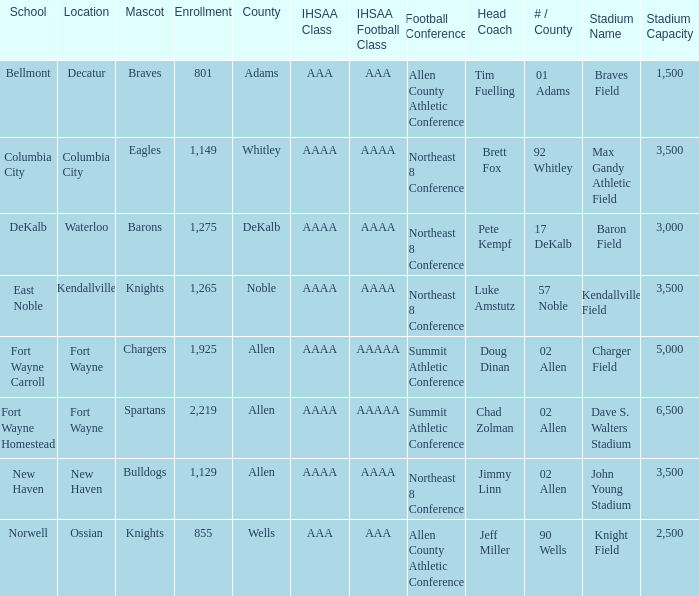What's the IHSAA Football Class in Decatur with an AAA IHSAA class? AAA. 